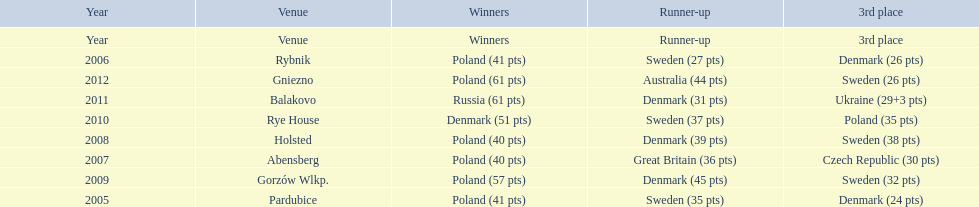Previous to 2008 how many times was sweden the runner up? 2. 